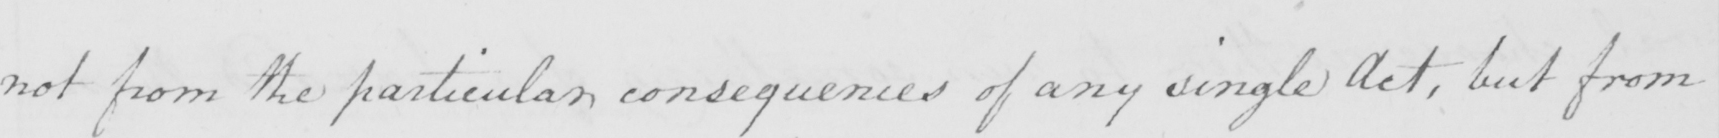What does this handwritten line say? not from the particular consequences of any single Act , but from 